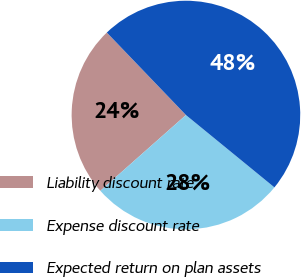Convert chart. <chart><loc_0><loc_0><loc_500><loc_500><pie_chart><fcel>Liability discount rate<fcel>Expense discount rate<fcel>Expected return on plan assets<nl><fcel>24.36%<fcel>27.56%<fcel>48.08%<nl></chart> 